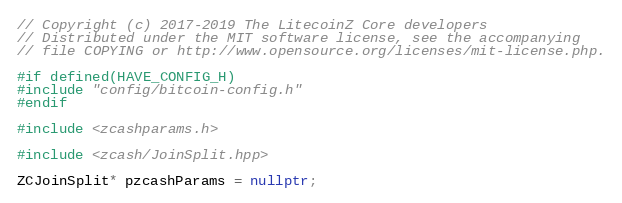<code> <loc_0><loc_0><loc_500><loc_500><_C++_>// Copyright (c) 2017-2019 The LitecoinZ Core developers
// Distributed under the MIT software license, see the accompanying
// file COPYING or http://www.opensource.org/licenses/mit-license.php.

#if defined(HAVE_CONFIG_H)
#include "config/bitcoin-config.h"
#endif

#include <zcashparams.h>

#include <zcash/JoinSplit.hpp>

ZCJoinSplit* pzcashParams = nullptr;
</code> 